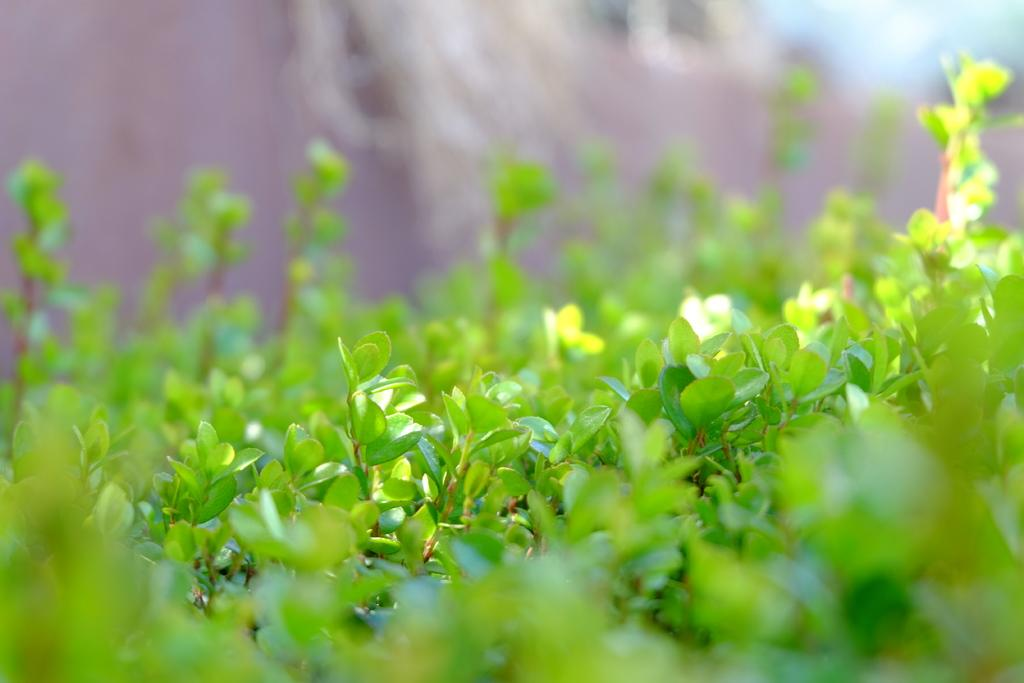What type of plants are visible in the image? There are green plants in the image. Where are the green plants located in the image? The green plants are in the middle of the image. What type of fowl can be seen playing chess in the image? There is no fowl or chess game present in the image; it features green plants in the middle. 